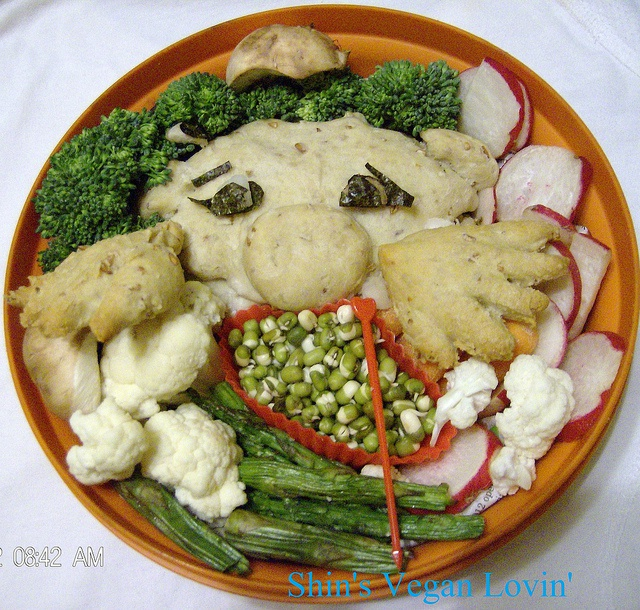Describe the objects in this image and their specific colors. I can see broccoli in darkgray, black, darkgreen, and olive tones and broccoli in darkgray, darkgreen, black, and olive tones in this image. 